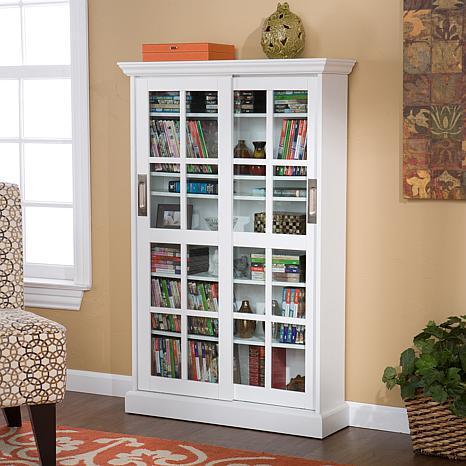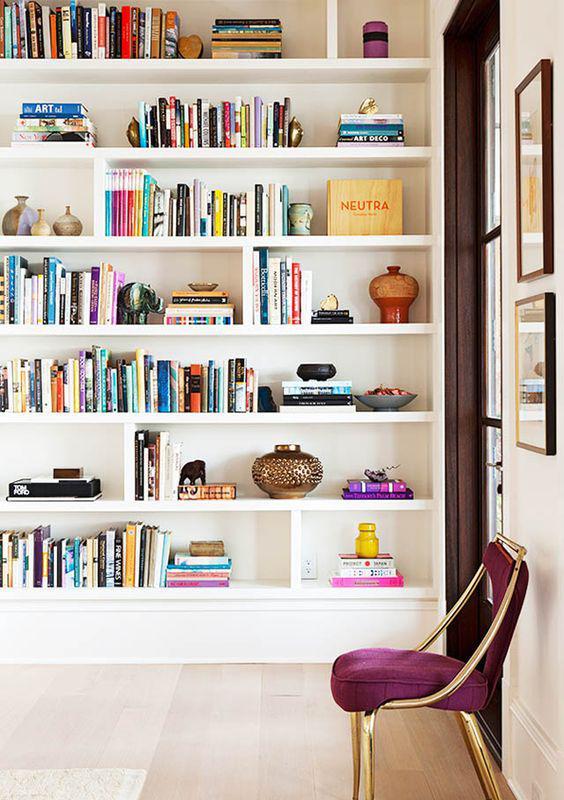The first image is the image on the left, the second image is the image on the right. Given the left and right images, does the statement "An image shows a non-white corner bookshelf that includes at least some open ends" hold true? Answer yes or no. No. 